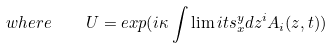Convert formula to latex. <formula><loc_0><loc_0><loc_500><loc_500>w h e r e \quad U = e x p ( i \kappa \int \lim i t s _ { x } ^ { y } d z ^ { i } A _ { i } ( z , t ) )</formula> 